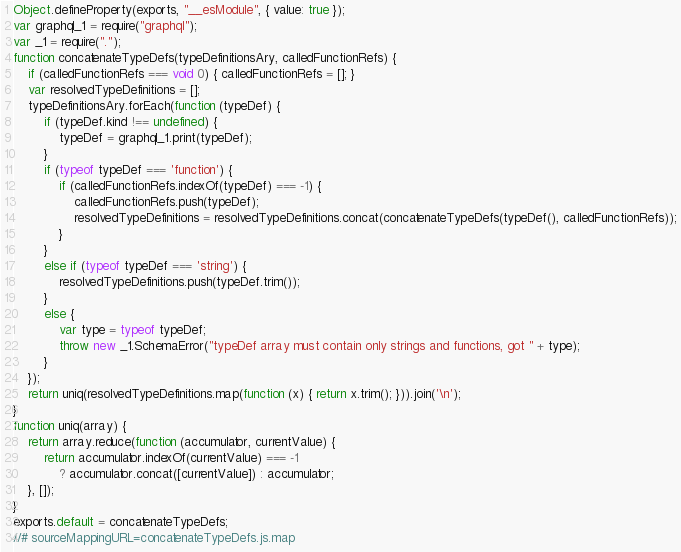Convert code to text. <code><loc_0><loc_0><loc_500><loc_500><_JavaScript_>Object.defineProperty(exports, "__esModule", { value: true });
var graphql_1 = require("graphql");
var _1 = require(".");
function concatenateTypeDefs(typeDefinitionsAry, calledFunctionRefs) {
    if (calledFunctionRefs === void 0) { calledFunctionRefs = []; }
    var resolvedTypeDefinitions = [];
    typeDefinitionsAry.forEach(function (typeDef) {
        if (typeDef.kind !== undefined) {
            typeDef = graphql_1.print(typeDef);
        }
        if (typeof typeDef === 'function') {
            if (calledFunctionRefs.indexOf(typeDef) === -1) {
                calledFunctionRefs.push(typeDef);
                resolvedTypeDefinitions = resolvedTypeDefinitions.concat(concatenateTypeDefs(typeDef(), calledFunctionRefs));
            }
        }
        else if (typeof typeDef === 'string') {
            resolvedTypeDefinitions.push(typeDef.trim());
        }
        else {
            var type = typeof typeDef;
            throw new _1.SchemaError("typeDef array must contain only strings and functions, got " + type);
        }
    });
    return uniq(resolvedTypeDefinitions.map(function (x) { return x.trim(); })).join('\n');
}
function uniq(array) {
    return array.reduce(function (accumulator, currentValue) {
        return accumulator.indexOf(currentValue) === -1
            ? accumulator.concat([currentValue]) : accumulator;
    }, []);
}
exports.default = concatenateTypeDefs;
//# sourceMappingURL=concatenateTypeDefs.js.map</code> 